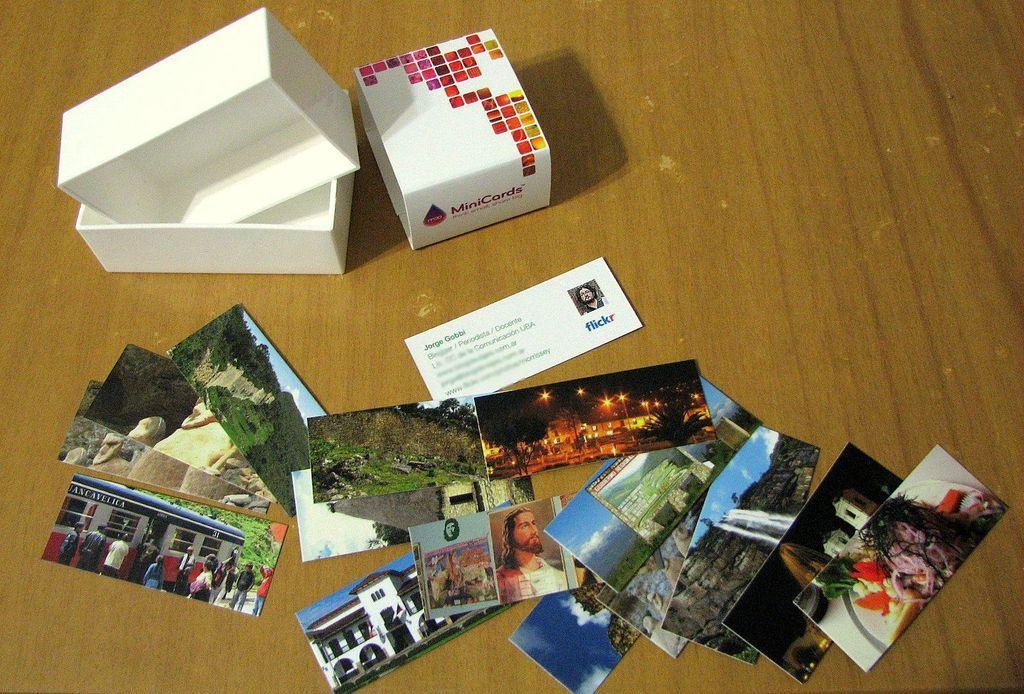In one or two sentences, can you explain what this image depicts? This image consists of photographs and a box are kept on the floor. 